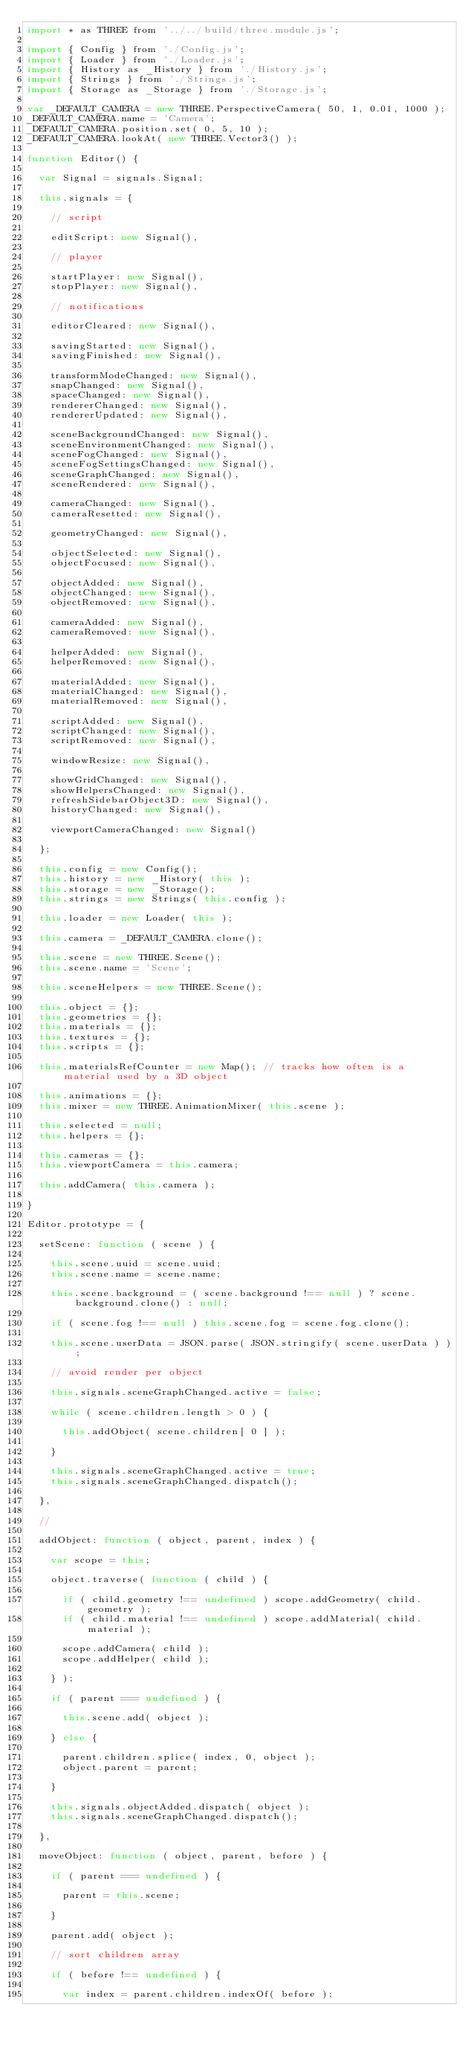Convert code to text. <code><loc_0><loc_0><loc_500><loc_500><_JavaScript_>import * as THREE from '../../build/three.module.js';

import { Config } from './Config.js';
import { Loader } from './Loader.js';
import { History as _History } from './History.js';
import { Strings } from './Strings.js';
import { Storage as _Storage } from './Storage.js';

var _DEFAULT_CAMERA = new THREE.PerspectiveCamera( 50, 1, 0.01, 1000 );
_DEFAULT_CAMERA.name = 'Camera';
_DEFAULT_CAMERA.position.set( 0, 5, 10 );
_DEFAULT_CAMERA.lookAt( new THREE.Vector3() );

function Editor() {

	var Signal = signals.Signal;

	this.signals = {

		// script

		editScript: new Signal(),

		// player

		startPlayer: new Signal(),
		stopPlayer: new Signal(),

		// notifications

		editorCleared: new Signal(),

		savingStarted: new Signal(),
		savingFinished: new Signal(),

		transformModeChanged: new Signal(),
		snapChanged: new Signal(),
		spaceChanged: new Signal(),
		rendererChanged: new Signal(),
		rendererUpdated: new Signal(),

		sceneBackgroundChanged: new Signal(),
		sceneEnvironmentChanged: new Signal(),
		sceneFogChanged: new Signal(),
		sceneFogSettingsChanged: new Signal(),
		sceneGraphChanged: new Signal(),
		sceneRendered: new Signal(),

		cameraChanged: new Signal(),
		cameraResetted: new Signal(),

		geometryChanged: new Signal(),

		objectSelected: new Signal(),
		objectFocused: new Signal(),

		objectAdded: new Signal(),
		objectChanged: new Signal(),
		objectRemoved: new Signal(),

		cameraAdded: new Signal(),
		cameraRemoved: new Signal(),

		helperAdded: new Signal(),
		helperRemoved: new Signal(),

		materialAdded: new Signal(),
		materialChanged: new Signal(),
		materialRemoved: new Signal(),

		scriptAdded: new Signal(),
		scriptChanged: new Signal(),
		scriptRemoved: new Signal(),

		windowResize: new Signal(),

		showGridChanged: new Signal(),
		showHelpersChanged: new Signal(),
		refreshSidebarObject3D: new Signal(),
		historyChanged: new Signal(),

		viewportCameraChanged: new Signal()

	};

	this.config = new Config();
	this.history = new _History( this );
	this.storage = new _Storage();
	this.strings = new Strings( this.config );

	this.loader = new Loader( this );

	this.camera = _DEFAULT_CAMERA.clone();

	this.scene = new THREE.Scene();
	this.scene.name = 'Scene';

	this.sceneHelpers = new THREE.Scene();

	this.object = {};
	this.geometries = {};
	this.materials = {};
	this.textures = {};
	this.scripts = {};

	this.materialsRefCounter = new Map(); // tracks how often is a material used by a 3D object

	this.animations = {};
	this.mixer = new THREE.AnimationMixer( this.scene );

	this.selected = null;
	this.helpers = {};

	this.cameras = {};
	this.viewportCamera = this.camera;

	this.addCamera( this.camera );

}

Editor.prototype = {

	setScene: function ( scene ) {

		this.scene.uuid = scene.uuid;
		this.scene.name = scene.name;

		this.scene.background = ( scene.background !== null ) ? scene.background.clone() : null;

		if ( scene.fog !== null ) this.scene.fog = scene.fog.clone();

		this.scene.userData = JSON.parse( JSON.stringify( scene.userData ) );

		// avoid render per object

		this.signals.sceneGraphChanged.active = false;

		while ( scene.children.length > 0 ) {

			this.addObject( scene.children[ 0 ] );

		}

		this.signals.sceneGraphChanged.active = true;
		this.signals.sceneGraphChanged.dispatch();

	},

	//

	addObject: function ( object, parent, index ) {

		var scope = this;

		object.traverse( function ( child ) {

			if ( child.geometry !== undefined ) scope.addGeometry( child.geometry );
			if ( child.material !== undefined ) scope.addMaterial( child.material );

			scope.addCamera( child );
			scope.addHelper( child );

		} );

		if ( parent === undefined ) {

			this.scene.add( object );

		} else {

			parent.children.splice( index, 0, object );
			object.parent = parent;

		}

		this.signals.objectAdded.dispatch( object );
		this.signals.sceneGraphChanged.dispatch();

	},

	moveObject: function ( object, parent, before ) {

		if ( parent === undefined ) {

			parent = this.scene;

		}

		parent.add( object );

		// sort children array

		if ( before !== undefined ) {

			var index = parent.children.indexOf( before );</code> 